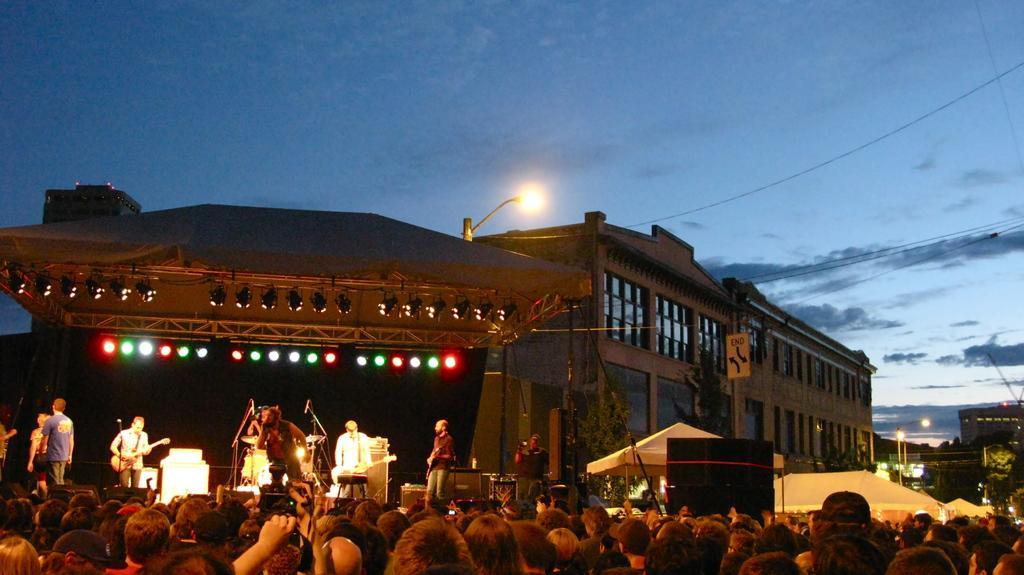In one or two sentences, can you explain what this image depicts? This picture is clicked outside. In the foreground we can see the group of persons and we can see the metal rods, focusing lights, tent. On the right we can see a black color object and we can see the tents. On the left we can see the group of persons standing and seems to be playing musical instruments and we can see the microphones, metal rods, focusing lights. In the background we can see the sky, cables, lights, buildings and some other objects. 